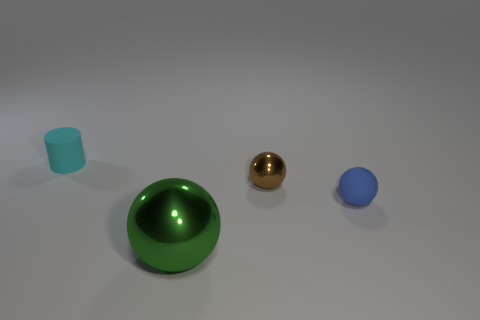What is the color of the small matte object to the left of the sphere left of the shiny ball behind the big green sphere? The small matte object situated to the left of the clear blue sphere, which is left of the shiny golden ball and behind the large green sphere, is cyan in color. Its matte surface contrasts with the shiny textures of the surrounding spheres, giving the object a distinguished look amidst the reflective items. 